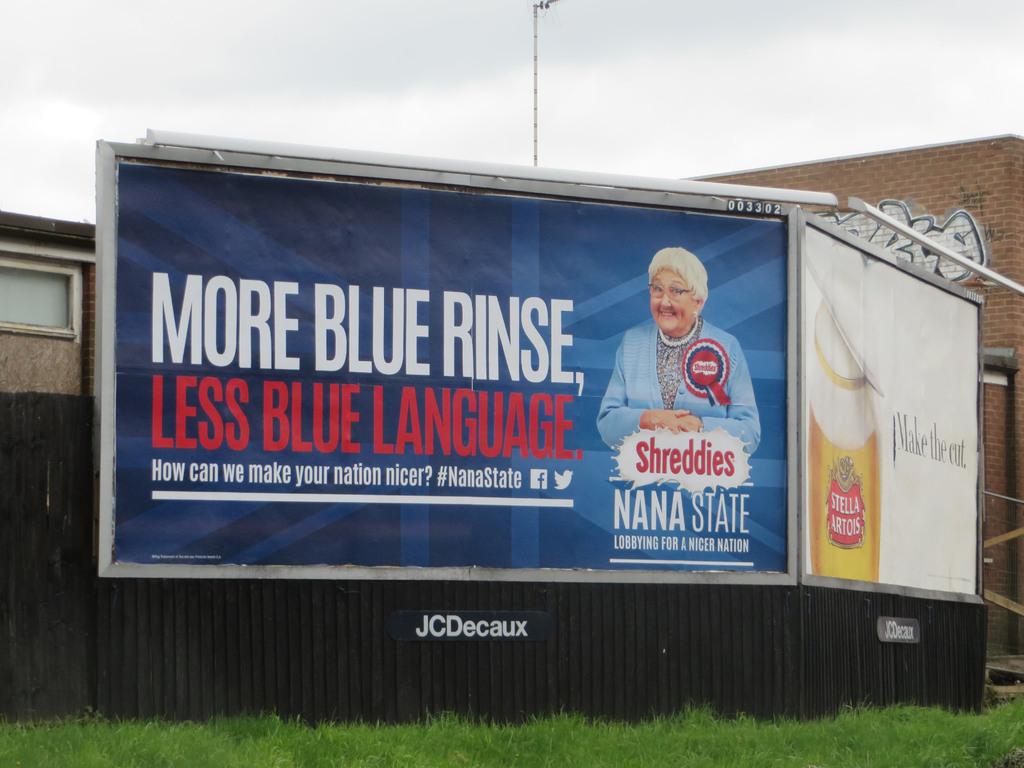What is the beer brand off to the side?
Provide a short and direct response. Stella artois. 